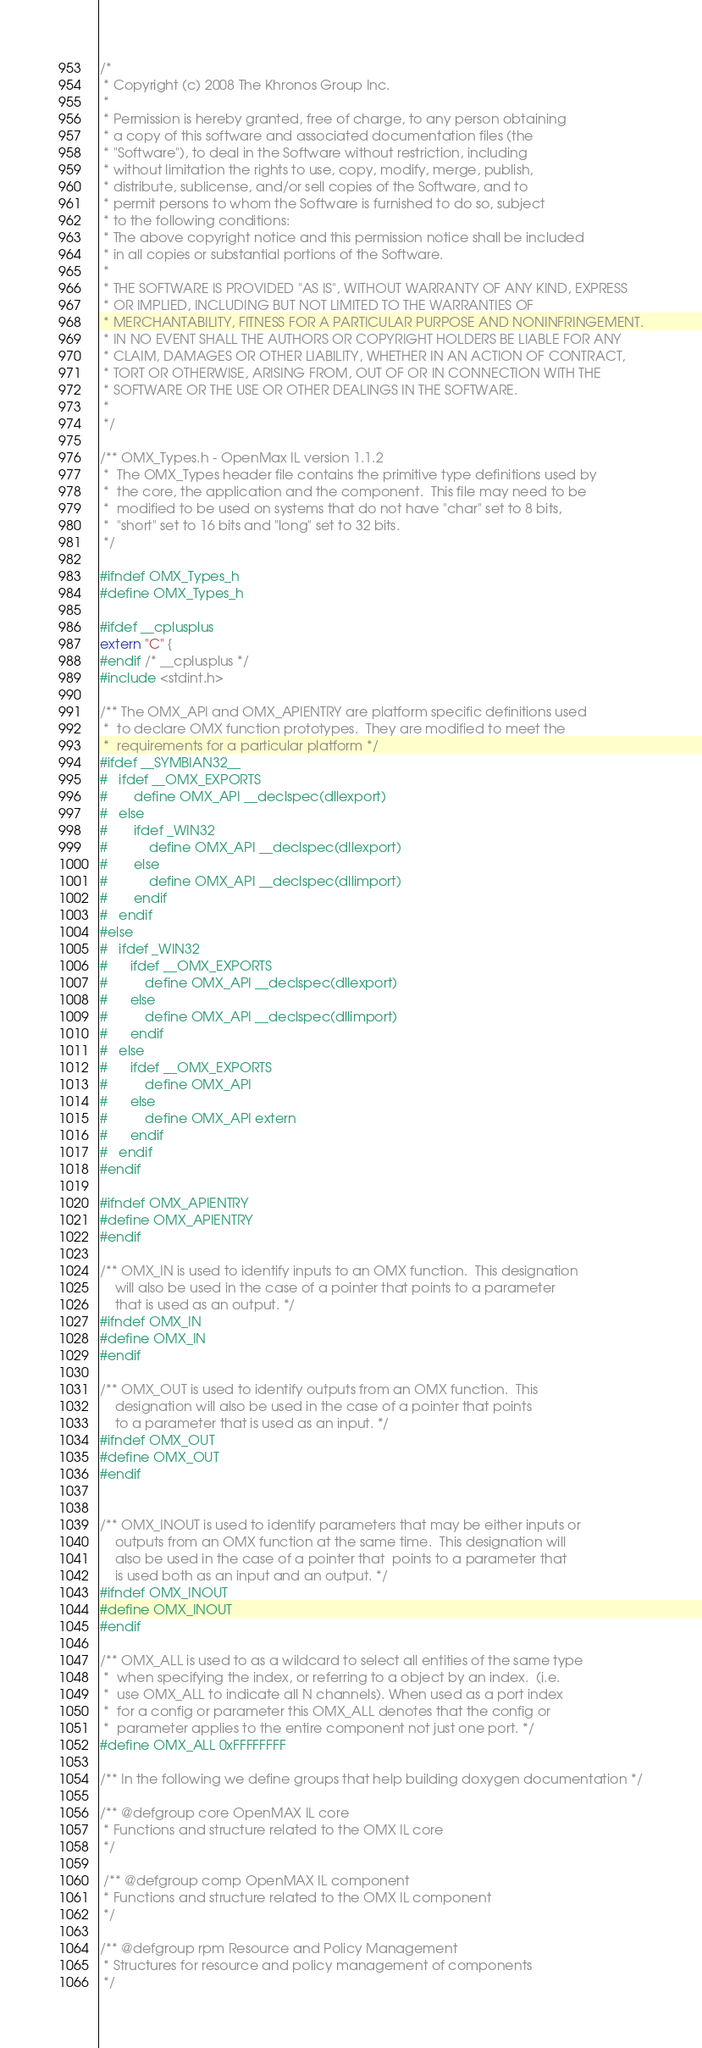<code> <loc_0><loc_0><loc_500><loc_500><_C_>/*
 * Copyright (c) 2008 The Khronos Group Inc. 
 * 
 * Permission is hereby granted, free of charge, to any person obtaining
 * a copy of this software and associated documentation files (the
 * "Software"), to deal in the Software without restriction, including
 * without limitation the rights to use, copy, modify, merge, publish,
 * distribute, sublicense, and/or sell copies of the Software, and to
 * permit persons to whom the Software is furnished to do so, subject
 * to the following conditions: 
 * The above copyright notice and this permission notice shall be included
 * in all copies or substantial portions of the Software. 
 * 
 * THE SOFTWARE IS PROVIDED "AS IS", WITHOUT WARRANTY OF ANY KIND, EXPRESS
 * OR IMPLIED, INCLUDING BUT NOT LIMITED TO THE WARRANTIES OF
 * MERCHANTABILITY, FITNESS FOR A PARTICULAR PURPOSE AND NONINFRINGEMENT.
 * IN NO EVENT SHALL THE AUTHORS OR COPYRIGHT HOLDERS BE LIABLE FOR ANY
 * CLAIM, DAMAGES OR OTHER LIABILITY, WHETHER IN AN ACTION OF CONTRACT,
 * TORT OR OTHERWISE, ARISING FROM, OUT OF OR IN CONNECTION WITH THE
 * SOFTWARE OR THE USE OR OTHER DEALINGS IN THE SOFTWARE. 
 *
 */

/** OMX_Types.h - OpenMax IL version 1.1.2
 *  The OMX_Types header file contains the primitive type definitions used by 
 *  the core, the application and the component.  This file may need to be
 *  modified to be used on systems that do not have "char" set to 8 bits, 
 *  "short" set to 16 bits and "long" set to 32 bits.
 */

#ifndef OMX_Types_h
#define OMX_Types_h

#ifdef __cplusplus
extern "C" {
#endif /* __cplusplus */
#include <stdint.h>

/** The OMX_API and OMX_APIENTRY are platform specific definitions used
 *  to declare OMX function prototypes.  They are modified to meet the
 *  requirements for a particular platform */
#ifdef __SYMBIAN32__   
#   ifdef __OMX_EXPORTS
#       define OMX_API __declspec(dllexport)
#   else
#       ifdef _WIN32
#           define OMX_API __declspec(dllexport) 
#       else
#           define OMX_API __declspec(dllimport)
#       endif
#   endif
#else
#   ifdef _WIN32
#      ifdef __OMX_EXPORTS
#          define OMX_API __declspec(dllexport)
#      else
#          define OMX_API __declspec(dllimport)
#      endif
#   else
#      ifdef __OMX_EXPORTS
#          define OMX_API
#      else
#          define OMX_API extern
#      endif
#   endif
#endif

#ifndef OMX_APIENTRY
#define OMX_APIENTRY 
#endif 

/** OMX_IN is used to identify inputs to an OMX function.  This designation 
    will also be used in the case of a pointer that points to a parameter 
    that is used as an output. */
#ifndef OMX_IN
#define OMX_IN
#endif

/** OMX_OUT is used to identify outputs from an OMX function.  This 
    designation will also be used in the case of a pointer that points 
    to a parameter that is used as an input. */
#ifndef OMX_OUT
#define OMX_OUT
#endif


/** OMX_INOUT is used to identify parameters that may be either inputs or
    outputs from an OMX function at the same time.  This designation will 
    also be used in the case of a pointer that  points to a parameter that 
    is used both as an input and an output. */
#ifndef OMX_INOUT
#define OMX_INOUT
#endif

/** OMX_ALL is used to as a wildcard to select all entities of the same type
 *  when specifying the index, or referring to a object by an index.  (i.e.
 *  use OMX_ALL to indicate all N channels). When used as a port index
 *  for a config or parameter this OMX_ALL denotes that the config or
 *  parameter applies to the entire component not just one port. */
#define OMX_ALL 0xFFFFFFFF

/** In the following we define groups that help building doxygen documentation */

/** @defgroup core OpenMAX IL core
 * Functions and structure related to the OMX IL core
 */
 
 /** @defgroup comp OpenMAX IL component
 * Functions and structure related to the OMX IL component
 */
 
/** @defgroup rpm Resource and Policy Management 
 * Structures for resource and policy management of components
 */
</code> 